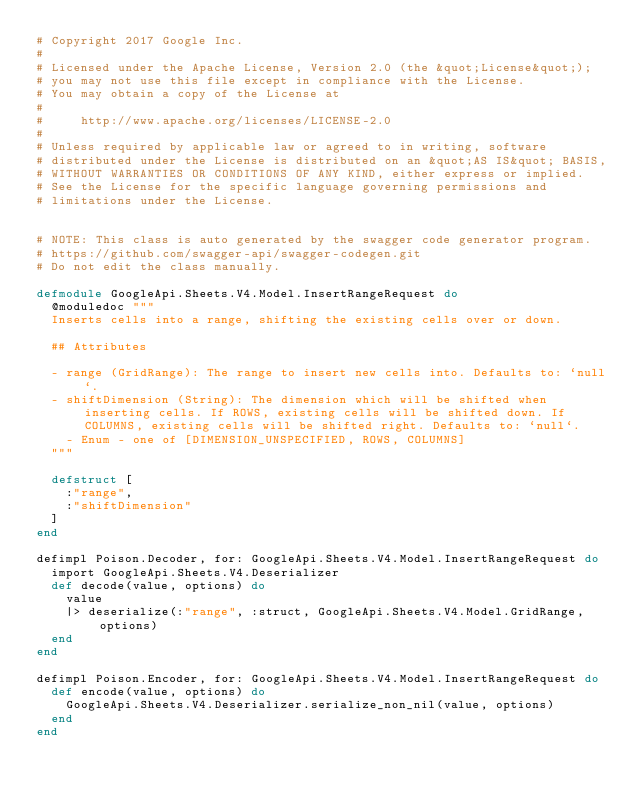Convert code to text. <code><loc_0><loc_0><loc_500><loc_500><_Elixir_># Copyright 2017 Google Inc.
#
# Licensed under the Apache License, Version 2.0 (the &quot;License&quot;);
# you may not use this file except in compliance with the License.
# You may obtain a copy of the License at
#
#     http://www.apache.org/licenses/LICENSE-2.0
#
# Unless required by applicable law or agreed to in writing, software
# distributed under the License is distributed on an &quot;AS IS&quot; BASIS,
# WITHOUT WARRANTIES OR CONDITIONS OF ANY KIND, either express or implied.
# See the License for the specific language governing permissions and
# limitations under the License.


# NOTE: This class is auto generated by the swagger code generator program.
# https://github.com/swagger-api/swagger-codegen.git
# Do not edit the class manually.

defmodule GoogleApi.Sheets.V4.Model.InsertRangeRequest do
  @moduledoc """
  Inserts cells into a range, shifting the existing cells over or down.

  ## Attributes

  - range (GridRange): The range to insert new cells into. Defaults to: `null`.
  - shiftDimension (String): The dimension which will be shifted when inserting cells. If ROWS, existing cells will be shifted down. If COLUMNS, existing cells will be shifted right. Defaults to: `null`.
    - Enum - one of [DIMENSION_UNSPECIFIED, ROWS, COLUMNS]
  """

  defstruct [
    :"range",
    :"shiftDimension"
  ]
end

defimpl Poison.Decoder, for: GoogleApi.Sheets.V4.Model.InsertRangeRequest do
  import GoogleApi.Sheets.V4.Deserializer
  def decode(value, options) do
    value
    |> deserialize(:"range", :struct, GoogleApi.Sheets.V4.Model.GridRange, options)
  end
end

defimpl Poison.Encoder, for: GoogleApi.Sheets.V4.Model.InsertRangeRequest do
  def encode(value, options) do
    GoogleApi.Sheets.V4.Deserializer.serialize_non_nil(value, options)
  end
end

</code> 